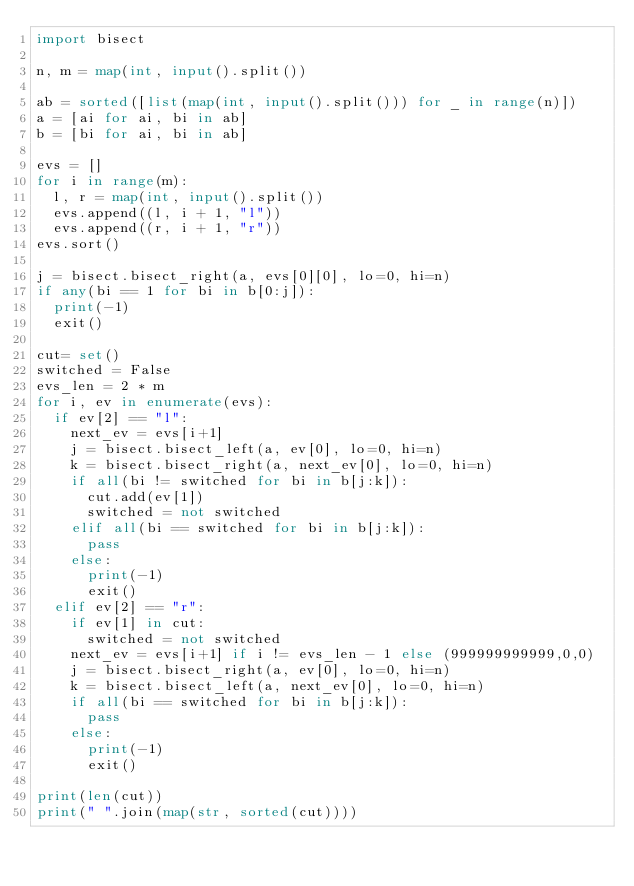Convert code to text. <code><loc_0><loc_0><loc_500><loc_500><_Python_>import bisect

n, m = map(int, input().split()) 

ab = sorted([list(map(int, input().split())) for _ in range(n)])
a = [ai for ai, bi in ab]
b = [bi for ai, bi in ab]

evs = []
for i in range(m):
  l, r = map(int, input().split())
  evs.append((l, i + 1, "l"))
  evs.append((r, i + 1, "r"))
evs.sort()

j = bisect.bisect_right(a, evs[0][0], lo=0, hi=n)
if any(bi == 1 for bi in b[0:j]):
  print(-1)
  exit()

cut= set()
switched = False
evs_len = 2 * m
for i, ev in enumerate(evs):
  if ev[2] == "l":
    next_ev = evs[i+1]    
    j = bisect.bisect_left(a, ev[0], lo=0, hi=n)
    k = bisect.bisect_right(a, next_ev[0], lo=0, hi=n)
    if all(bi != switched for bi in b[j:k]):
      cut.add(ev[1])
      switched = not switched
    elif all(bi == switched for bi in b[j:k]):
      pass
    else:
      print(-1)
      exit()
  elif ev[2] == "r": 
    if ev[1] in cut:
      switched = not switched
    next_ev = evs[i+1] if i != evs_len - 1 else (999999999999,0,0)
    j = bisect.bisect_right(a, ev[0], lo=0, hi=n)
    k = bisect.bisect_left(a, next_ev[0], lo=0, hi=n)
    if all(bi == switched for bi in b[j:k]):
      pass
    else:
      print(-1)
      exit()

print(len(cut))
print(" ".join(map(str, sorted(cut))))
</code> 